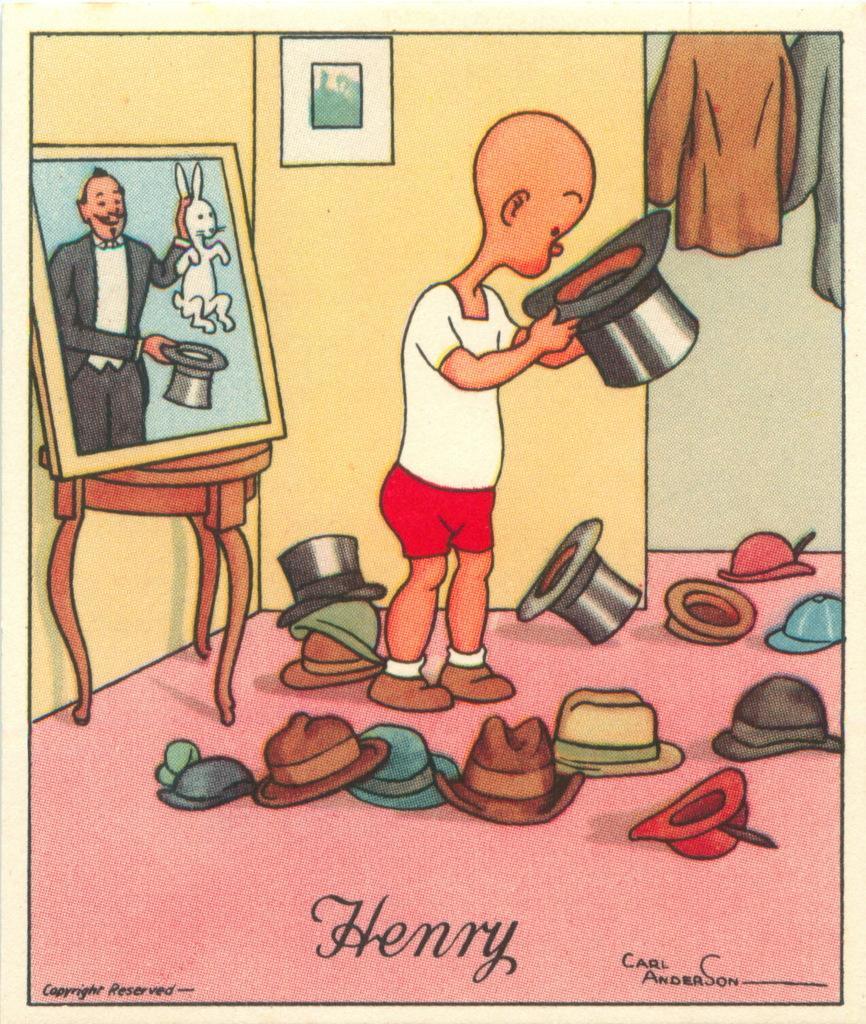Could you give a brief overview of what you see in this image? The picture is an animation. In the center of the picture we can see hats and a person holding hat. On the left there is a frame, stool and wall. In the background there is a wall and frame. On the right there are clothes. At the bottom we can see text. 